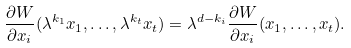Convert formula to latex. <formula><loc_0><loc_0><loc_500><loc_500>\frac { \partial W } { \partial x _ { i } } ( \lambda ^ { k _ { 1 } } x _ { 1 } , \dots , \lambda ^ { k _ { t } } x _ { t } ) = \lambda ^ { d - k _ { i } } \frac { \partial W } { \partial x _ { i } } ( x _ { 1 } , \dots , x _ { t } ) .</formula> 